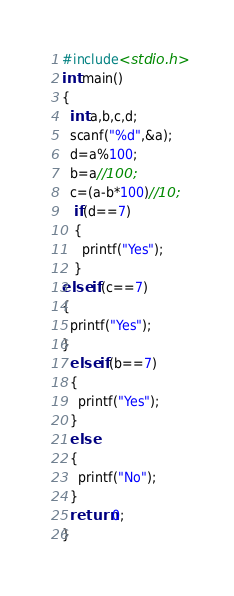<code> <loc_0><loc_0><loc_500><loc_500><_C_>#include<stdio.h>
int main()
{
  int a,b,c,d;
  scanf("%d",&a);
  d=a%100;
  b=a//100;
  c=(a-b*100)//10;
   if(d==7)
   {
     printf("Yes");
   }
else if(c==7)
{
  printf("Yes");
}
  else if(b==7)
  {
    printf("Yes");
  }
  else
  {
    printf("No");
  }
  return 0;
}</code> 